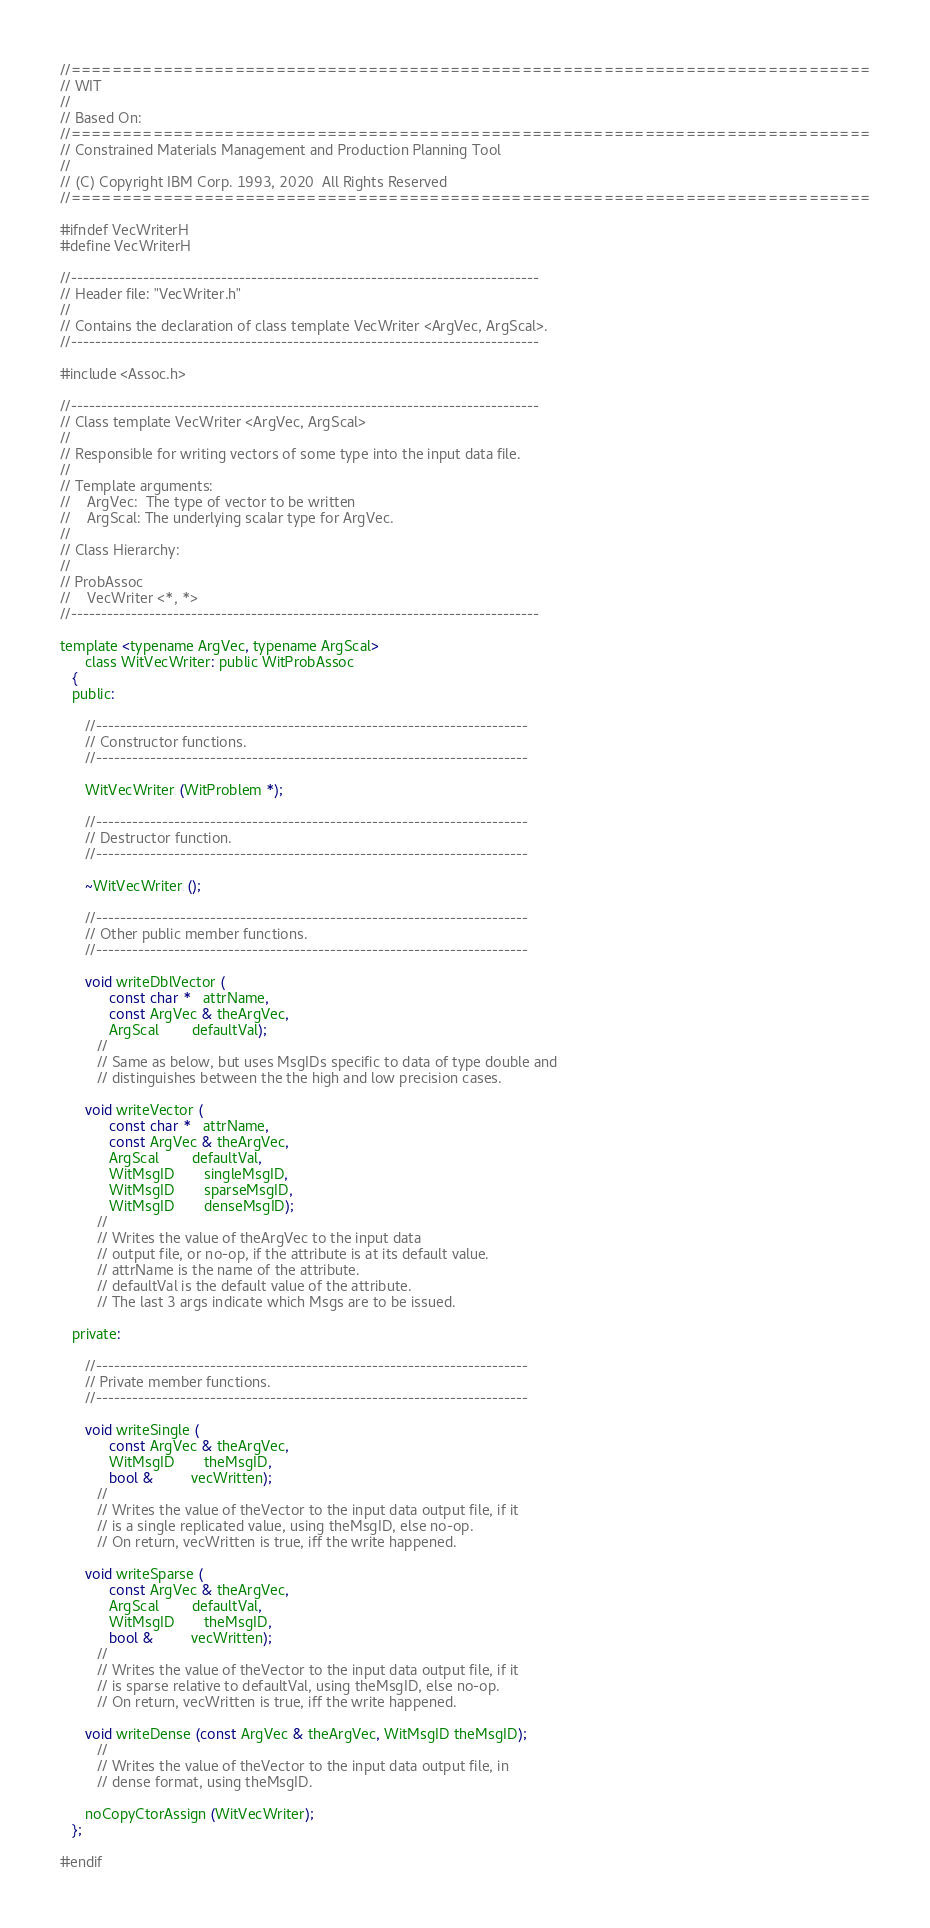<code> <loc_0><loc_0><loc_500><loc_500><_C_>//==============================================================================
// WIT
//
// Based On:
//==============================================================================
// Constrained Materials Management and Production Planning Tool
//
// (C) Copyright IBM Corp. 1993, 2020  All Rights Reserved
//==============================================================================

#ifndef VecWriterH
#define VecWriterH

//------------------------------------------------------------------------------
// Header file: "VecWriter.h"
//
// Contains the declaration of class template VecWriter <ArgVec, ArgScal>.
//------------------------------------------------------------------------------

#include <Assoc.h>

//------------------------------------------------------------------------------
// Class template VecWriter <ArgVec, ArgScal>
//
// Responsible for writing vectors of some type into the input data file.
//
// Template arguments:
//    ArgVec:  The type of vector to be written
//    ArgScal: The underlying scalar type for ArgVec.
//
// Class Hierarchy:
//
// ProbAssoc
//    VecWriter <*, *>
//------------------------------------------------------------------------------

template <typename ArgVec, typename ArgScal>
      class WitVecWriter: public WitProbAssoc
   {
   public:

      //------------------------------------------------------------------------
      // Constructor functions.
      //------------------------------------------------------------------------

      WitVecWriter (WitProblem *);

      //------------------------------------------------------------------------
      // Destructor function.
      //------------------------------------------------------------------------

      ~WitVecWriter ();

      //------------------------------------------------------------------------
      // Other public member functions.
      //------------------------------------------------------------------------

      void writeDblVector (
            const char *   attrName,
            const ArgVec & theArgVec,
            ArgScal        defaultVal);
         //
         // Same as below, but uses MsgIDs specific to data of type double and
         // distinguishes between the the high and low precision cases.

      void writeVector (
            const char *   attrName,
            const ArgVec & theArgVec,
            ArgScal        defaultVal,
            WitMsgID       singleMsgID,
            WitMsgID       sparseMsgID,
            WitMsgID       denseMsgID);
         //
         // Writes the value of theArgVec to the input data
         // output file, or no-op, if the attribute is at its default value.
         // attrName is the name of the attribute.
         // defaultVal is the default value of the attribute.
         // The last 3 args indicate which Msgs are to be issued.

   private:

      //------------------------------------------------------------------------
      // Private member functions.
      //------------------------------------------------------------------------

      void writeSingle (
            const ArgVec & theArgVec,
            WitMsgID       theMsgID,
            bool &         vecWritten);
         //
         // Writes the value of theVector to the input data output file, if it
         // is a single replicated value, using theMsgID, else no-op.
         // On return, vecWritten is true, iff the write happened.

      void writeSparse (
            const ArgVec & theArgVec,
            ArgScal        defaultVal,
            WitMsgID       theMsgID,
            bool &         vecWritten);
         //
         // Writes the value of theVector to the input data output file, if it
         // is sparse relative to defaultVal, using theMsgID, else no-op.
         // On return, vecWritten is true, iff the write happened.

      void writeDense (const ArgVec & theArgVec, WitMsgID theMsgID);
         //
         // Writes the value of theVector to the input data output file, in
         // dense format, using theMsgID.

      noCopyCtorAssign (WitVecWriter);
   };

#endif
</code> 